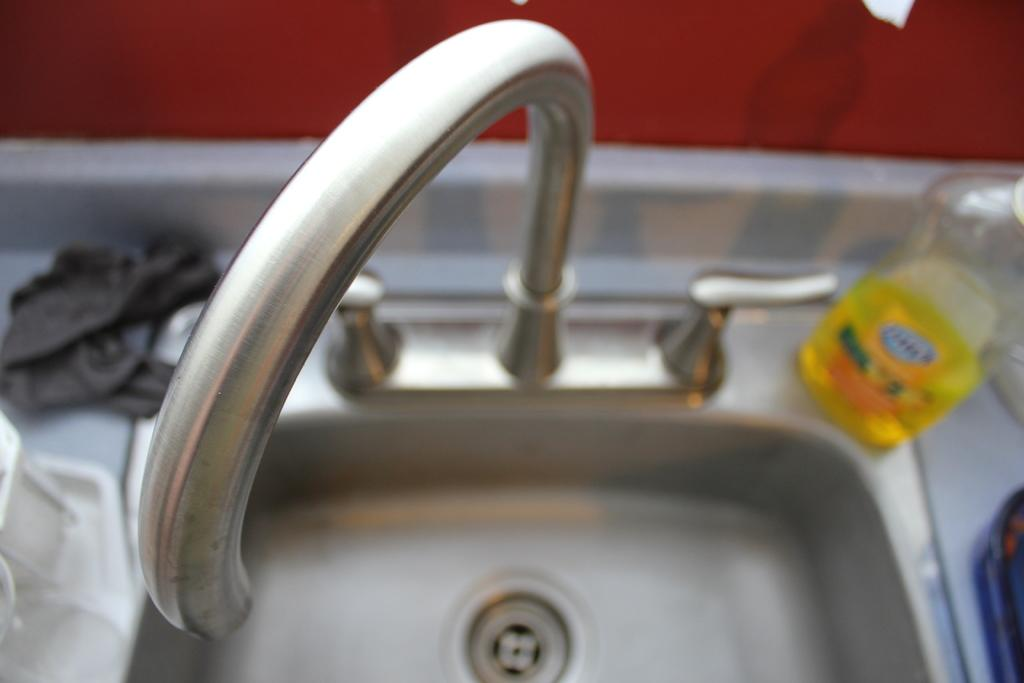What is located in the picture? There is a sink in the picture. What is in the middle of the sink? There is a tap in the middle of the sink. What is on the sink? There is a dish wash on the sink. What is on the left side of the sink? There is a cloth on the left side of the sink. How does the liquid walk from the tap to the dish wash in the image? A: There is no liquid or walking involved in the image; it only shows a sink with a tap, dish wash, and cloth. 